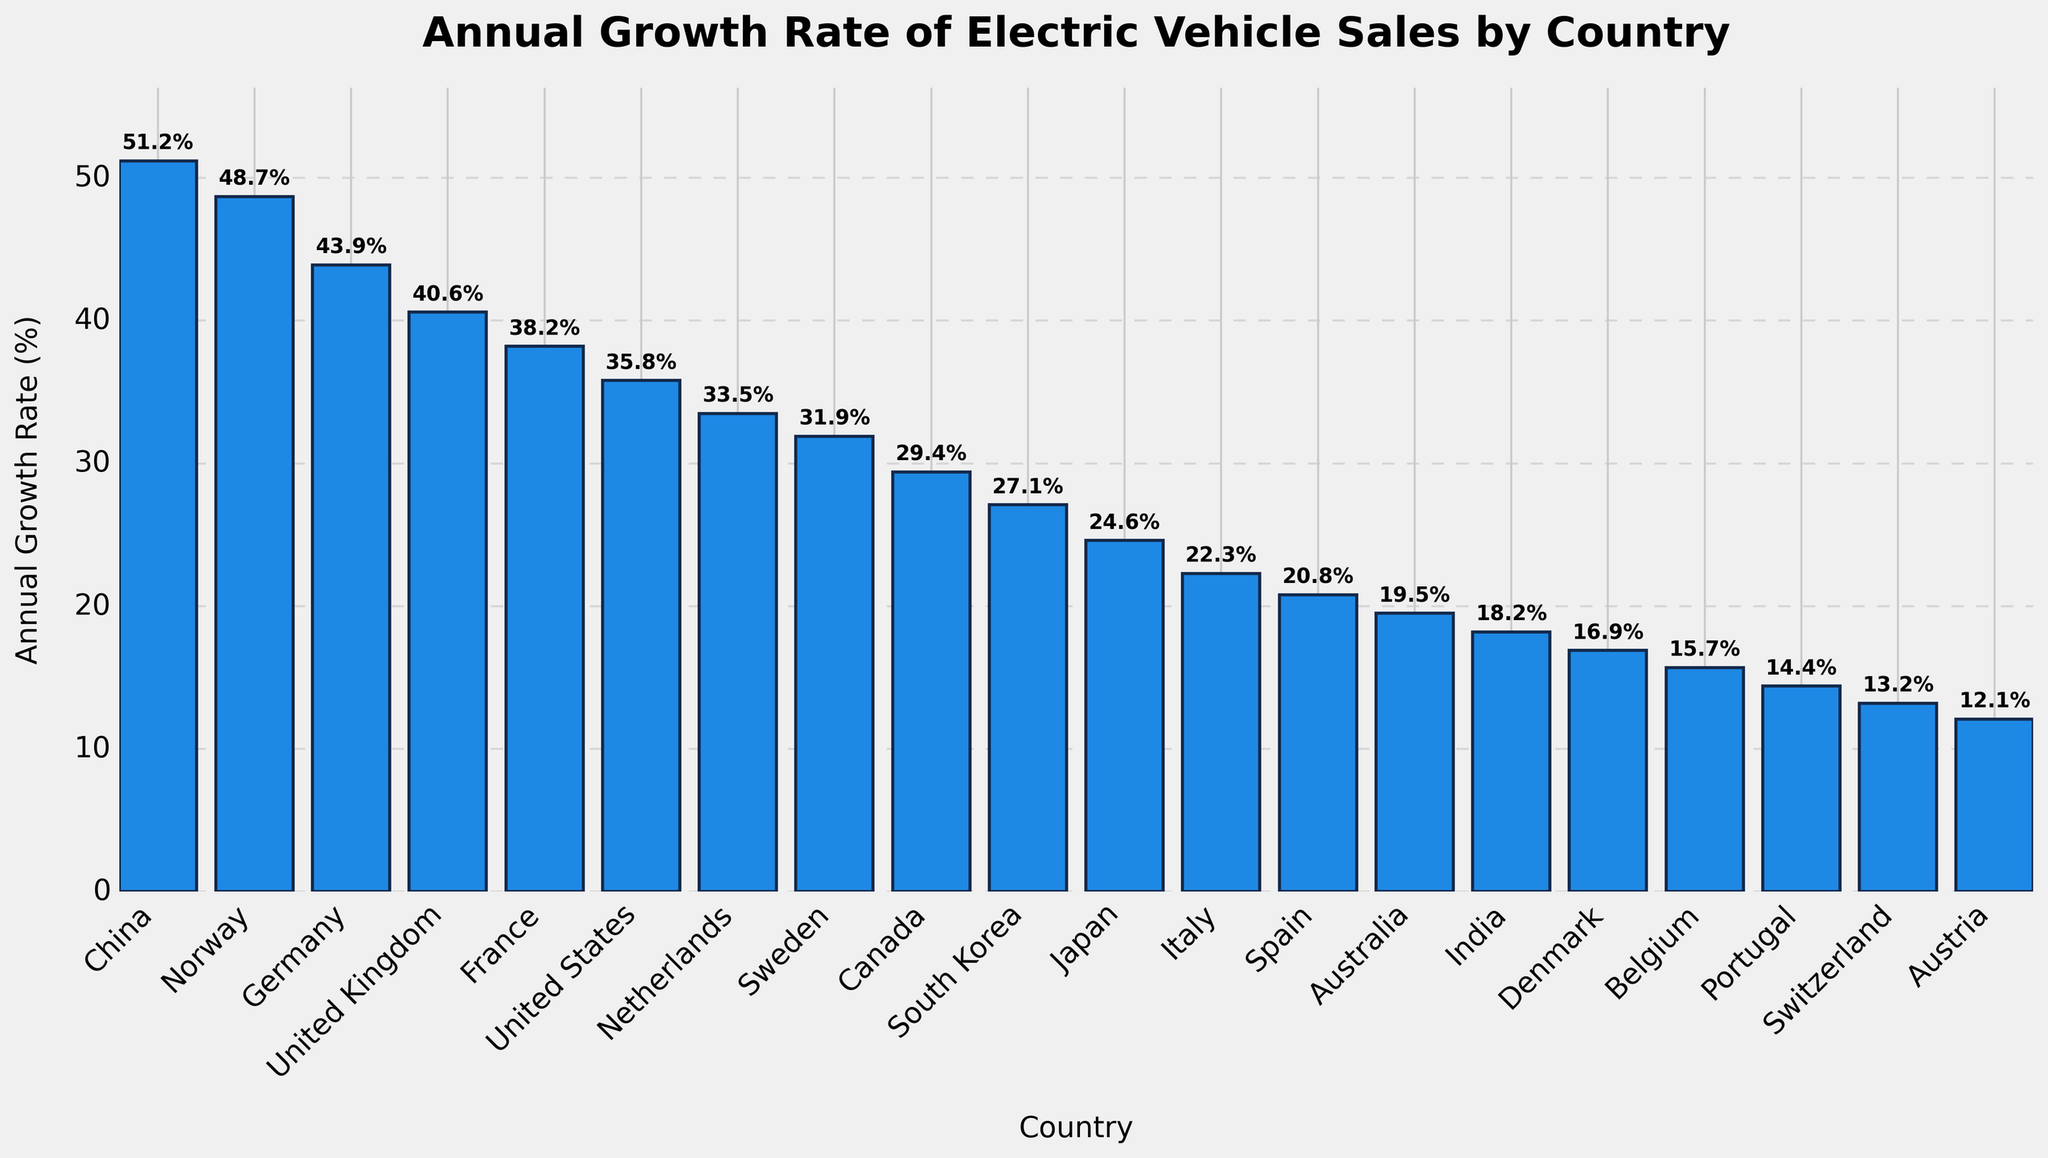What's the country with the highest annual growth rate of electric vehicle sales? To find the country with the highest growth rate, we look for the tallest bar in the plot. The tallest bar represents China with a growth rate of 51.2%.
Answer: China Which two countries have similar growth rates around 40%? Look for bars with heights close to 40%. United Kingdom (40.6%) and France (38.2%) both have growth rates near 40%.
Answer: United Kingdom and France What is the difference in annual growth rate between Germany and the United States? Identify the heights of the bars for Germany (43.9%) and the United States (35.8%), then subtract the latter from the former: 43.9 - 35.8 = 8.1.
Answer: 8.1% Which country has the lowest annual growth rate and what is the value? Identify the shortest bar in the plot, which represents Austria with a growth rate of 12.1%.
Answer: Austria, 12.1% Are there any countries with an annual growth rate below 20%? If so, which ones? Look for countries with bars below the 20% mark. Australia (19.5%), India (18.2%), Denmark (16.9%), Belgium (15.7%), Portugal (14.4%), Switzerland (13.2%), and Austria (12.1%) fit this criterion.
Answer: Australia, India, Denmark, Belgium, Portugal, Switzerland, Austria What's the combined growth rate of Norway and Sweden? Identify the bars for Norway (48.7%) and Sweden (31.9%), then sum these values: 48.7 + 31.9 = 80.6.
Answer: 80.6% How does the growth rate of France compare to Canada? Identify the heights of the bars for France (38.2%) and Canada (29.4%), then compare them. France has a higher growth rate than Canada.
Answer: France has a higher rate What is the average annual growth rate of electric vehicle sales among the top 5 countries? Identify the top 5 countries: China (51.2%), Norway (48.7%), Germany (43.9%), United Kingdom (40.6%), and France (38.2%). Calculate the average: (51.2 + 48.7 + 43.9 + 40.6 + 38.2) / 5 = 44.52.
Answer: 44.52% Which countries have growth rates between 25% and 35%? Look for countries with bars in this range. The United States (35.8%), Netherlands (33.5%), Sweden (31.9%), and Canada (29.4%) all fit.
Answer: United States, Netherlands, Sweden, Canada How many countries have a growth rate above 30%? Count the number of bars above the 30% mark. These countries are China, Norway, Germany, United Kingdom, France, United States, Netherlands, and Sweden, totaling 8.
Answer: 8 